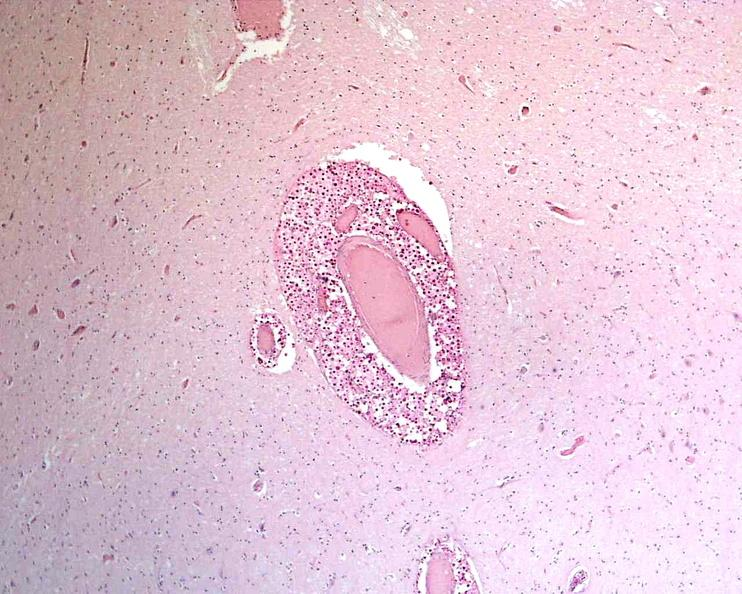do mucicarmine stain?
Answer the question using a single word or phrase. Yes 